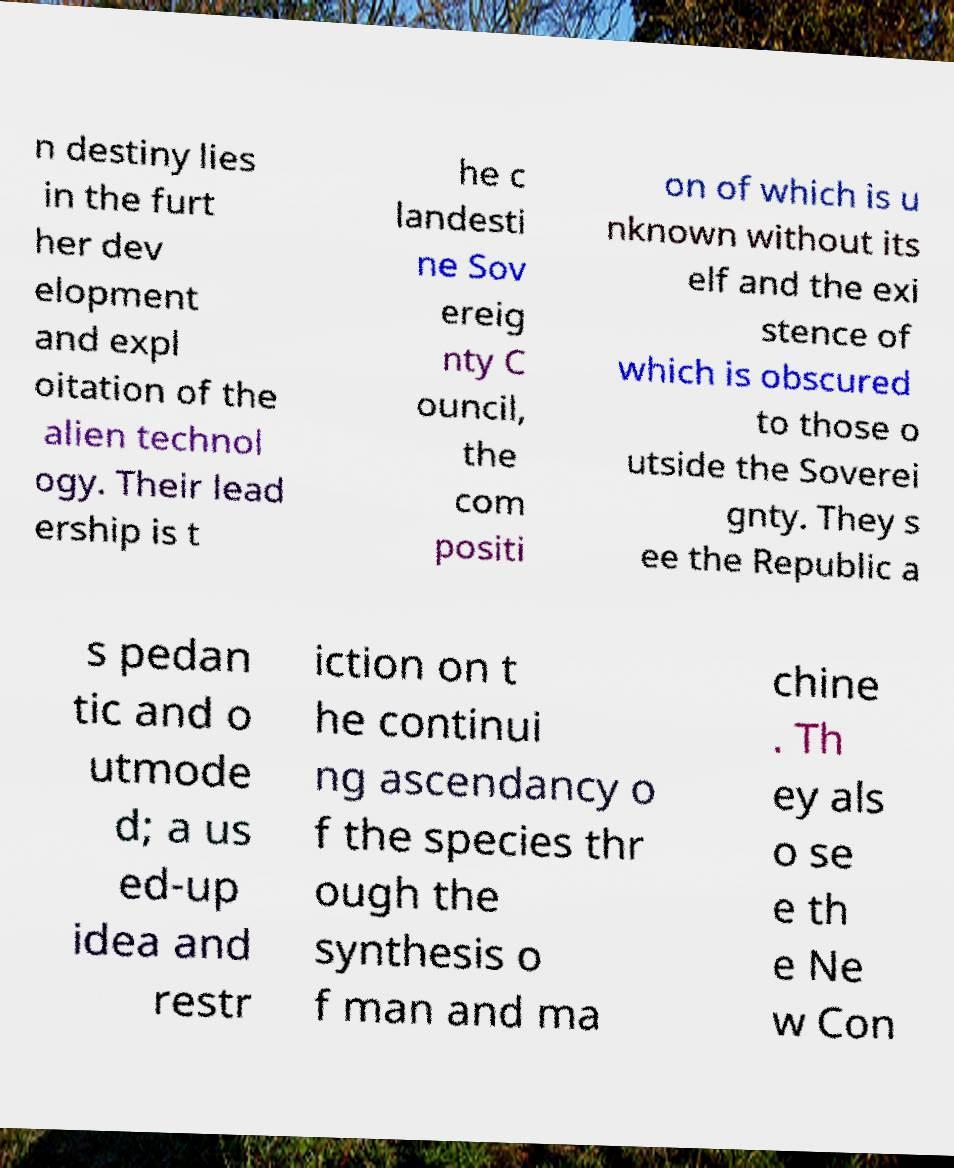What messages or text are displayed in this image? I need them in a readable, typed format. n destiny lies in the furt her dev elopment and expl oitation of the alien technol ogy. Their lead ership is t he c landesti ne Sov ereig nty C ouncil, the com positi on of which is u nknown without its elf and the exi stence of which is obscured to those o utside the Soverei gnty. They s ee the Republic a s pedan tic and o utmode d; a us ed-up idea and restr iction on t he continui ng ascendancy o f the species thr ough the synthesis o f man and ma chine . Th ey als o se e th e Ne w Con 